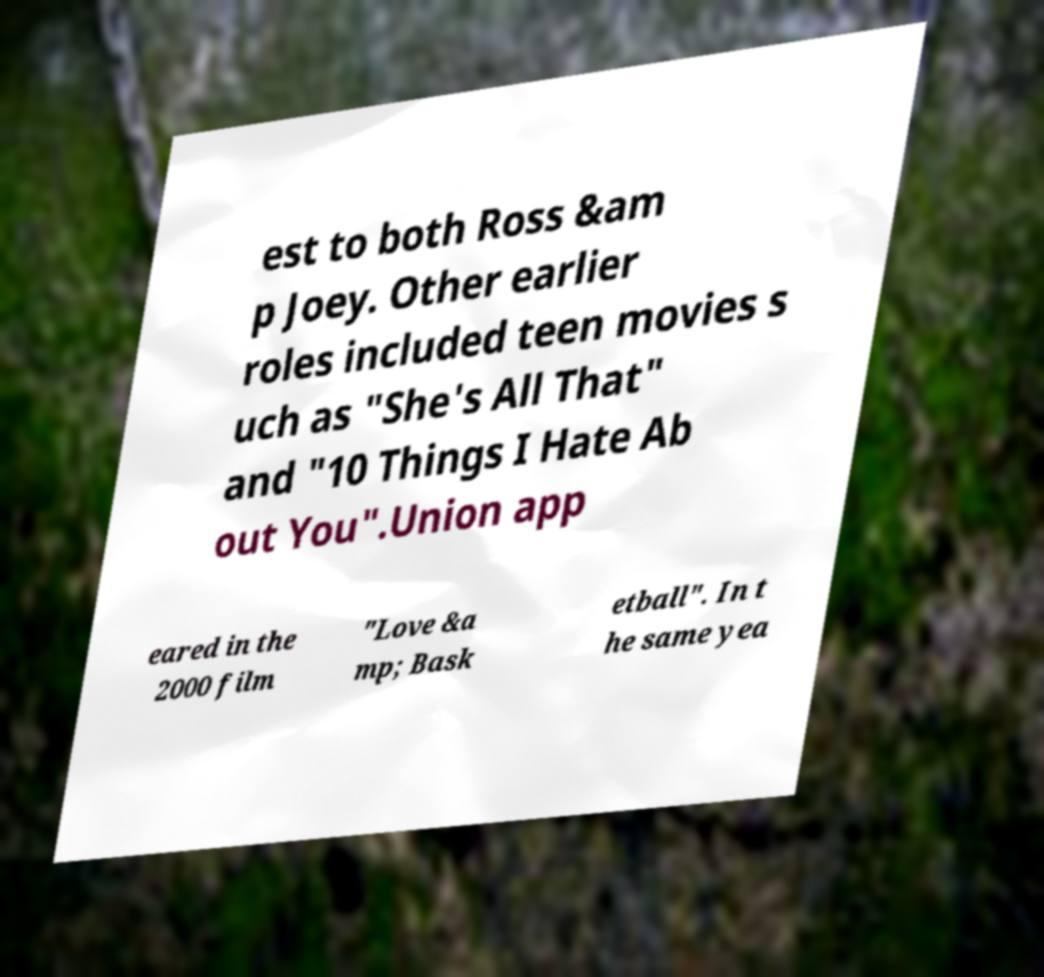I need the written content from this picture converted into text. Can you do that? est to both Ross &am p Joey. Other earlier roles included teen movies s uch as "She's All That" and "10 Things I Hate Ab out You".Union app eared in the 2000 film "Love &a mp; Bask etball". In t he same yea 